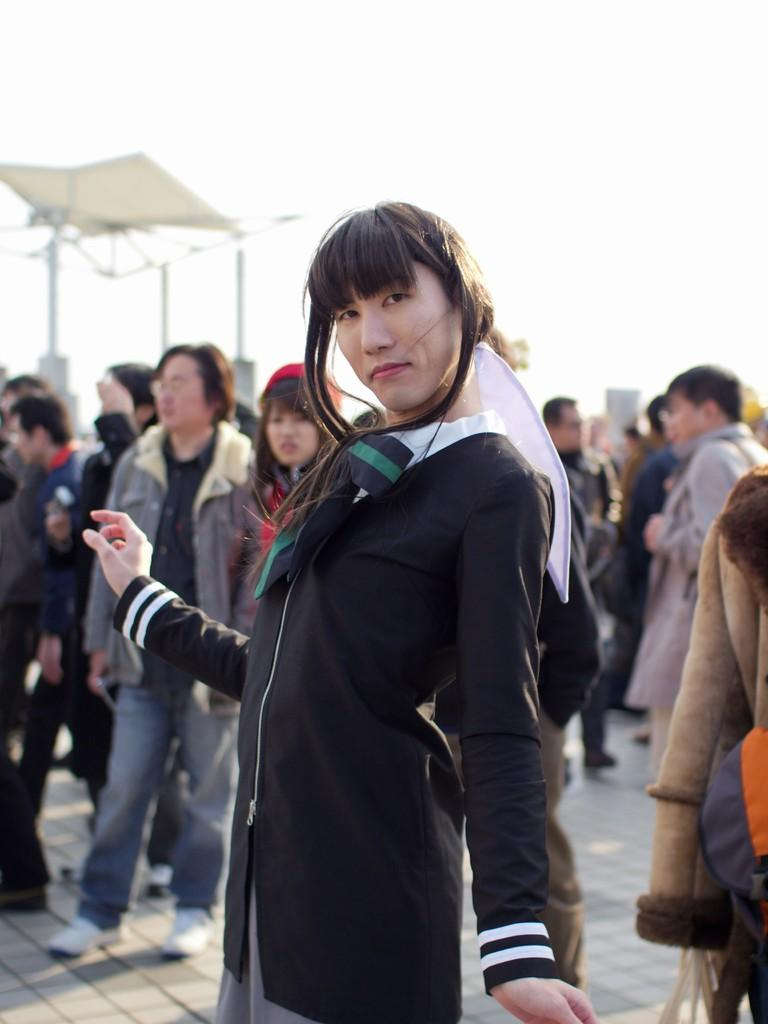How many people are present in the image? There are many people in the image. What are the people wearing? The people are wearing clothes. What type of path can be seen in the image? There is a footpath in the image. What is visible in the background of the image? There is a sky visible in the image. Can you describe a person with a specific clothing item in the image? Yes, there is a person wearing a red color cap in the image. What type of nail is being hammered into the tree in the image? There is no nail or tree present in the image; it features many people and a footpath. 